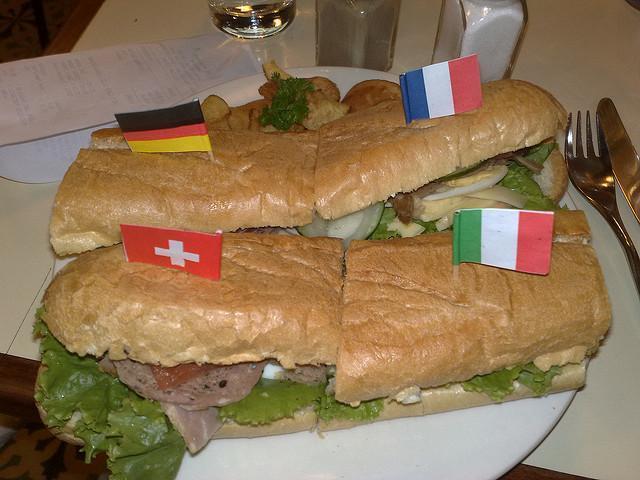How many countries are reflected in this photo?
Give a very brief answer. 4. How many forks are there?
Give a very brief answer. 1. How many dining tables are in the picture?
Give a very brief answer. 2. How many sandwiches are in the picture?
Give a very brief answer. 3. 